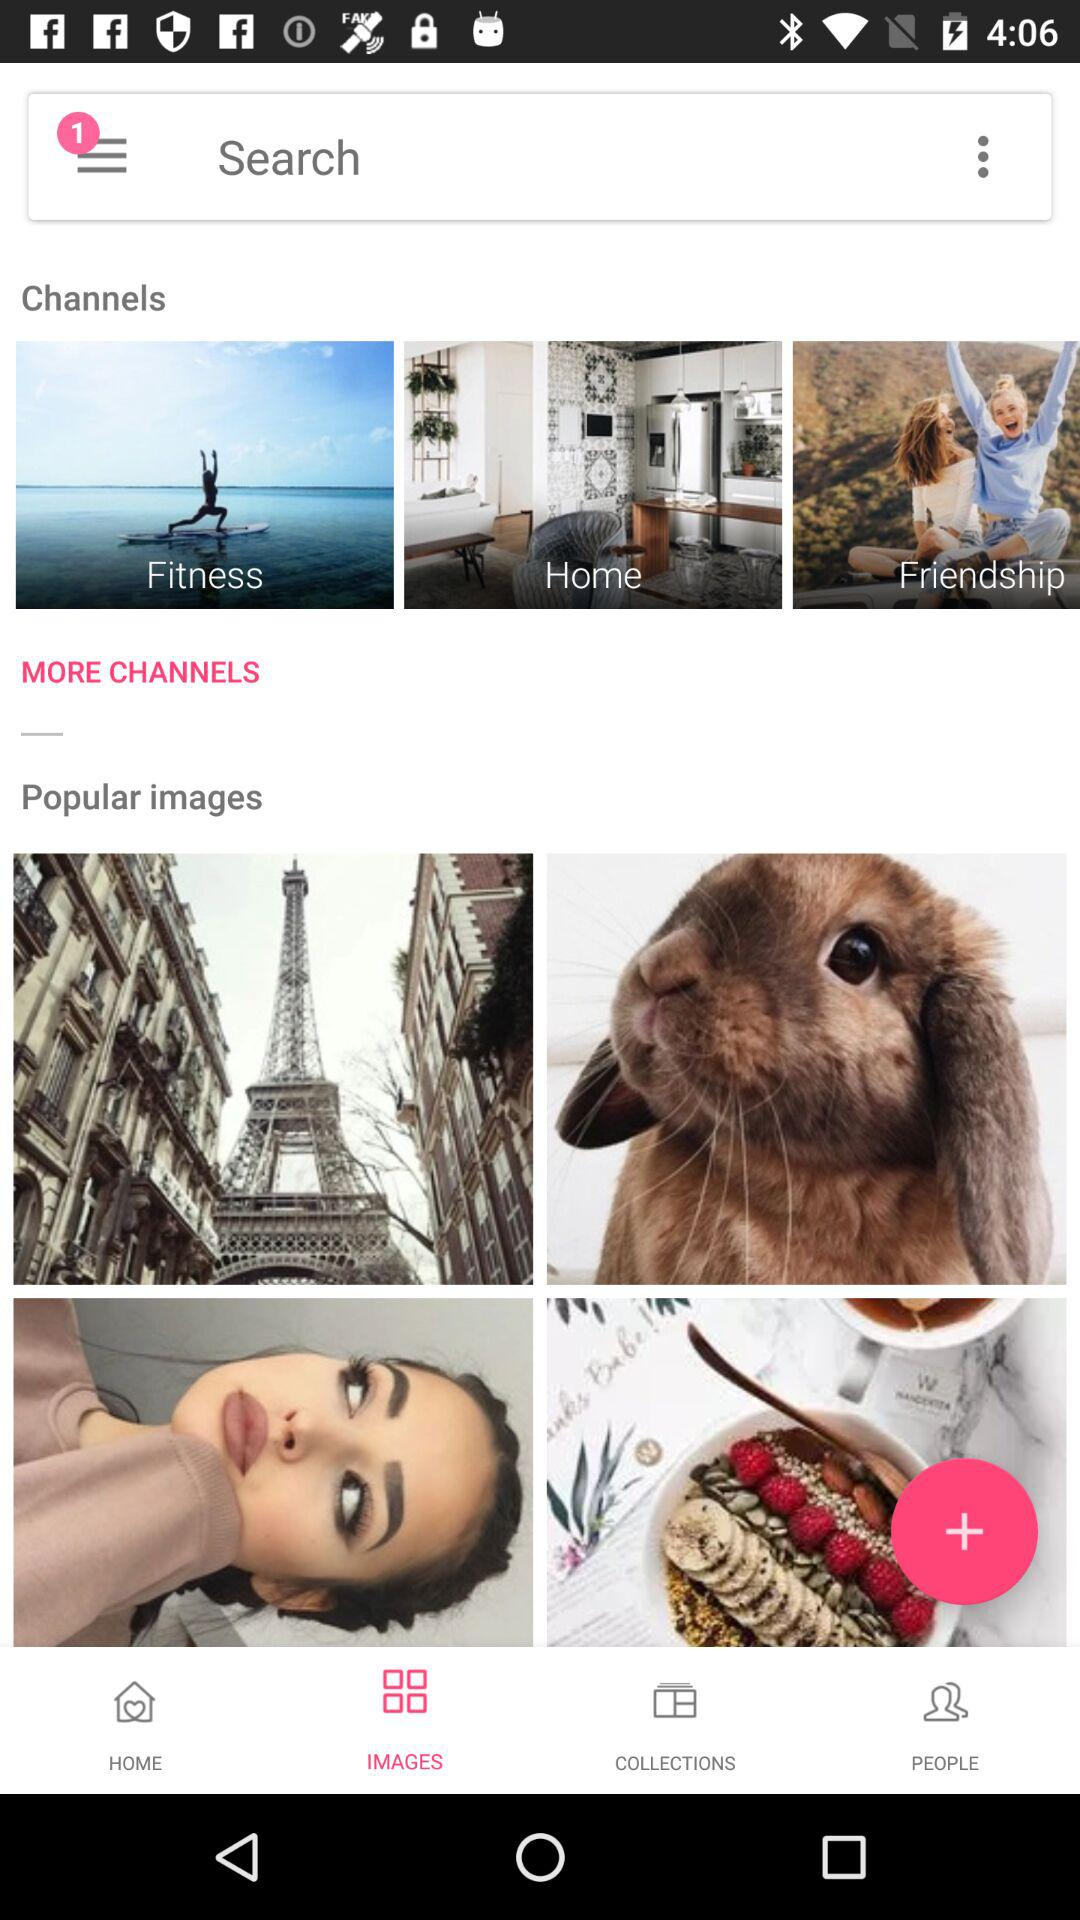How many notifications are pending? There is 1 pending notification. 